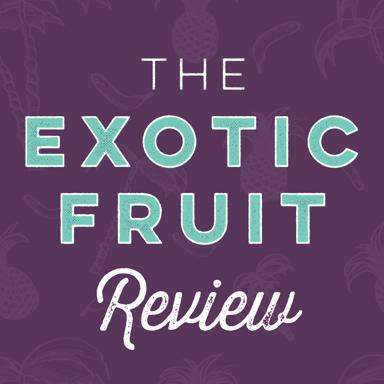Can you suggest a suitable audience for this type of promotional material? The ideal audience for this promotional material would be food enthusiasts, chefs, culinary students, and anyone interested in learning about different types of exotic fruits and their culinary applications. 